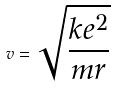Convert formula to latex. <formula><loc_0><loc_0><loc_500><loc_500>v = \sqrt { \frac { k e ^ { 2 } } { m r } }</formula> 